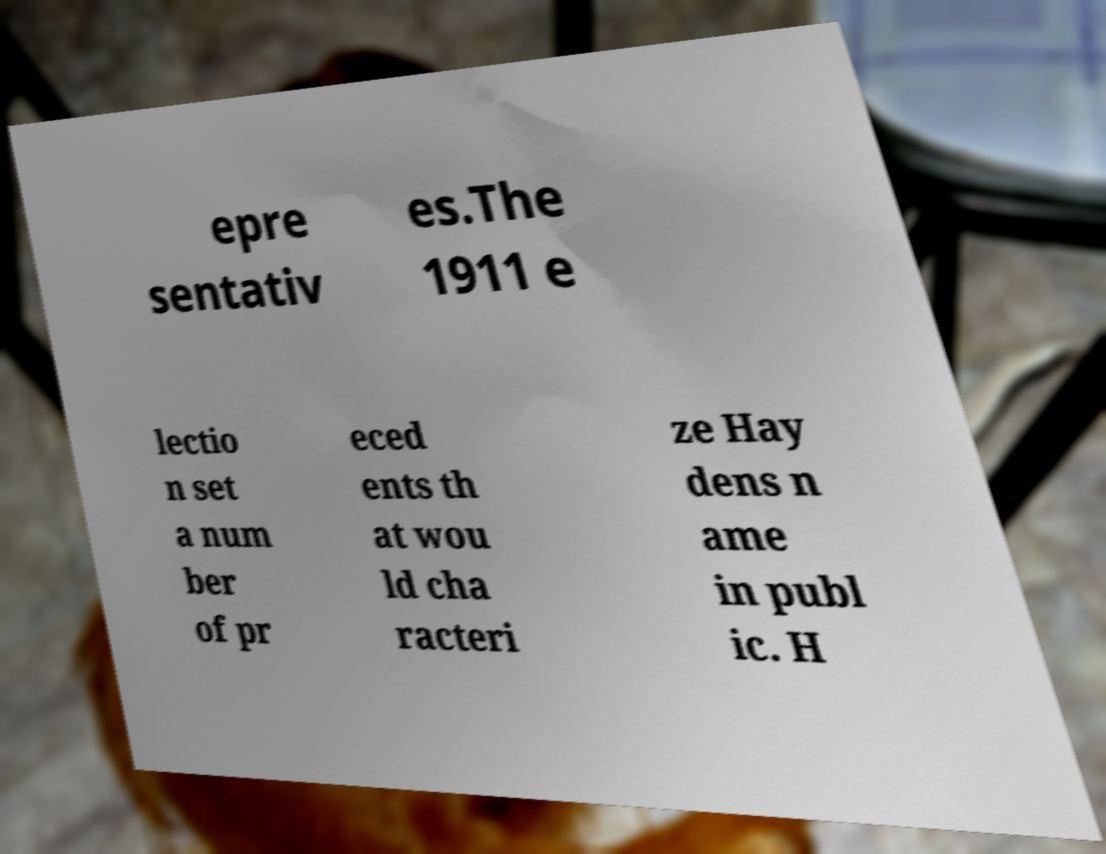Can you read and provide the text displayed in the image?This photo seems to have some interesting text. Can you extract and type it out for me? epre sentativ es.The 1911 e lectio n set a num ber of pr eced ents th at wou ld cha racteri ze Hay dens n ame in publ ic. H 